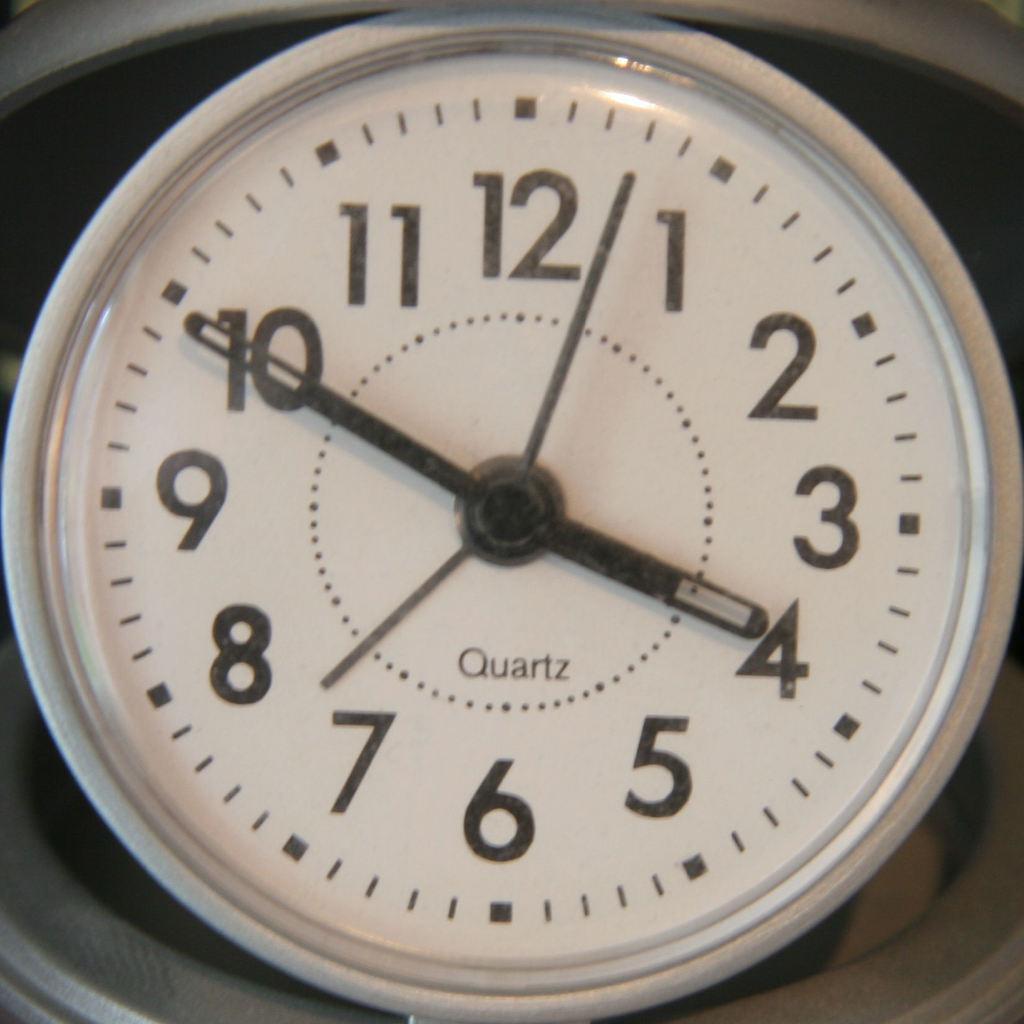<image>
Describe the image concisely. A white faced Quartz clock sits at 3:50. 